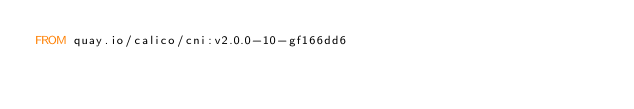Convert code to text. <code><loc_0><loc_0><loc_500><loc_500><_Dockerfile_>FROM quay.io/calico/cni:v2.0.0-10-gf166dd6
</code> 